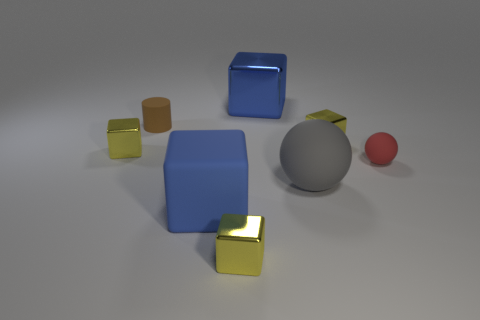Is the number of blue shiny things on the right side of the gray ball less than the number of small spheres?
Your answer should be very brief. Yes. Are there any small matte things that are on the left side of the tiny yellow block to the right of the blue object that is to the right of the big blue rubber thing?
Your answer should be compact. Yes. Is the material of the small cylinder the same as the blue thing behind the large ball?
Keep it short and to the point. No. There is a small metallic thing that is behind the yellow metal cube that is on the left side of the blue rubber cube; what is its color?
Your response must be concise. Yellow. Are there any big rubber balls that have the same color as the large matte cube?
Your answer should be very brief. No. There is a yellow block left of the brown rubber thing behind the yellow thing that is in front of the large rubber block; how big is it?
Provide a short and direct response. Small. There is a large blue shiny object; does it have the same shape as the yellow thing in front of the big matte ball?
Your answer should be very brief. Yes. How many other things are there of the same size as the matte cylinder?
Give a very brief answer. 4. There is a metallic block that is in front of the big matte ball; what is its size?
Give a very brief answer. Small. How many other big things have the same material as the big gray thing?
Offer a terse response. 1. 